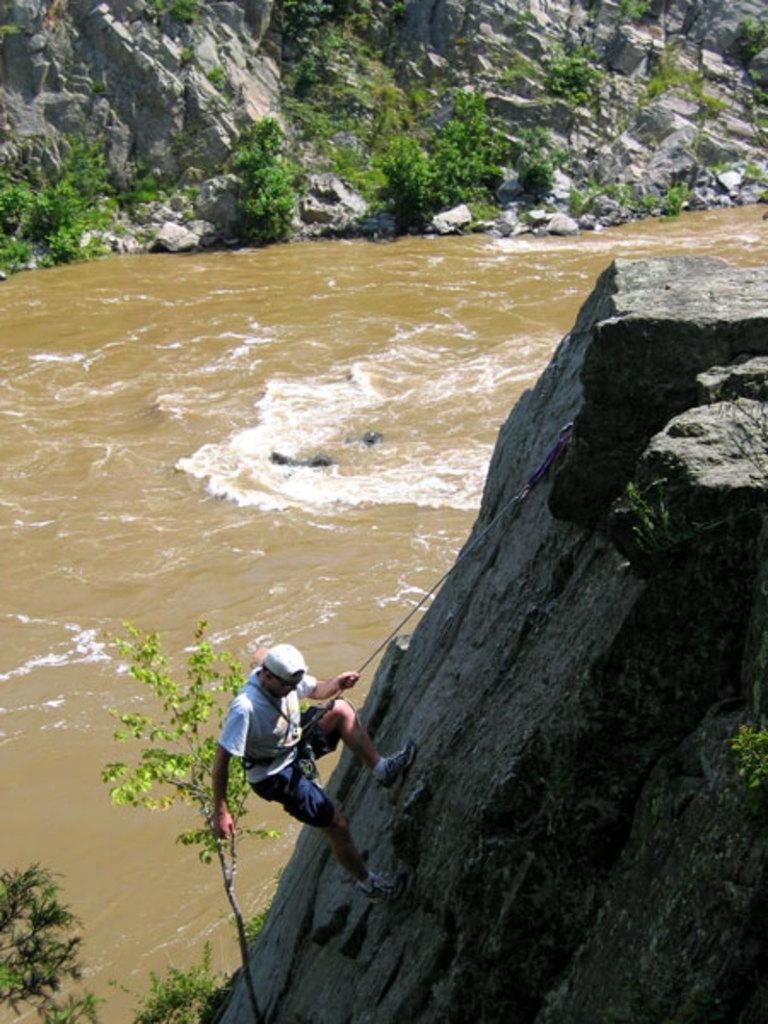Describe this image in one or two sentences. In this image we can see a man climbing the hill, river and plants. 